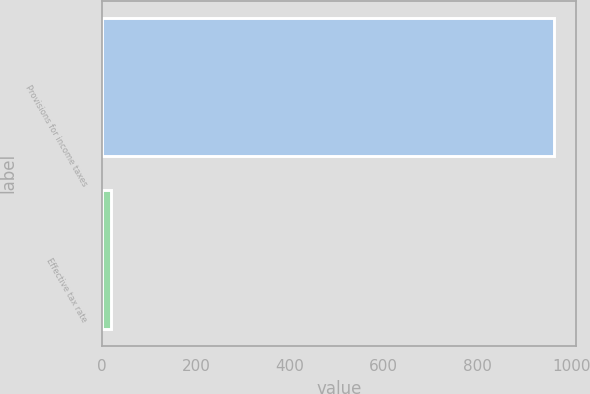<chart> <loc_0><loc_0><loc_500><loc_500><bar_chart><fcel>Provisions for income taxes<fcel>Effective tax rate<nl><fcel>963<fcel>19.2<nl></chart> 